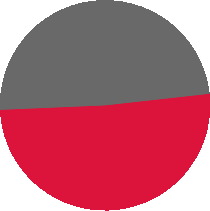Convert chart to OTSL. <chart><loc_0><loc_0><loc_500><loc_500><pie_chart><fcel>Year Ended December 31 2006<fcel>Year Ended December 31 2005<nl><fcel>51.08%<fcel>48.92%<nl></chart> 